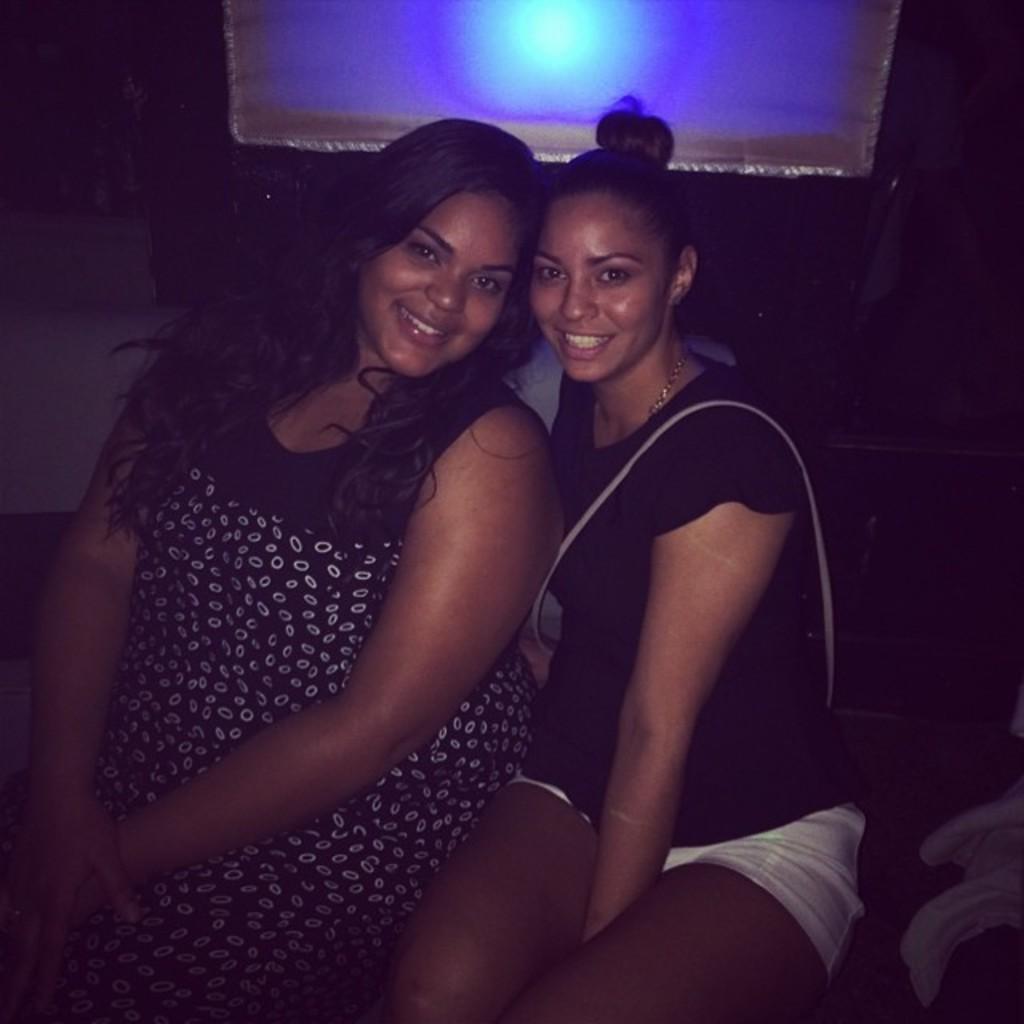How would you summarize this image in a sentence or two? In this image, we can see two people sitting. In the background, we can see some light. We can see some cloth with objects on it. 